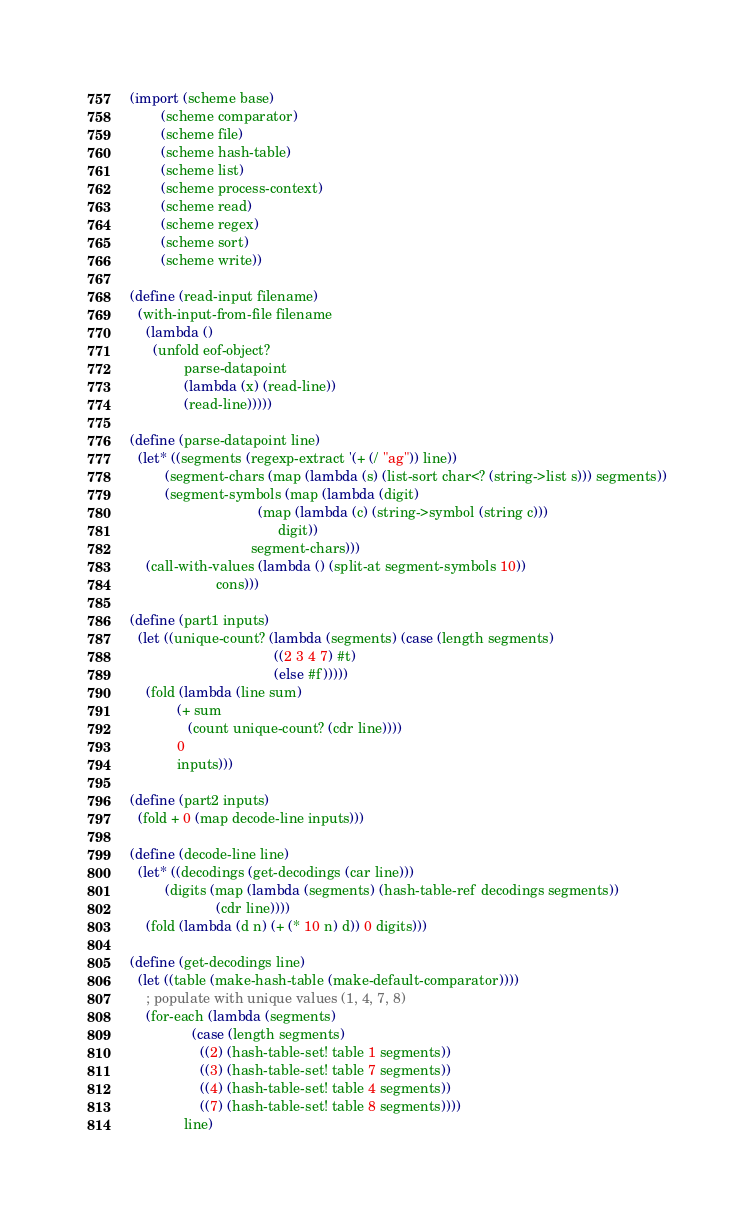<code> <loc_0><loc_0><loc_500><loc_500><_Scheme_>(import (scheme base)
        (scheme comparator)
        (scheme file)
        (scheme hash-table)
        (scheme list)
        (scheme process-context)
        (scheme read)
        (scheme regex)
        (scheme sort)
        (scheme write))

(define (read-input filename)
  (with-input-from-file filename
    (lambda ()
      (unfold eof-object?
              parse-datapoint
              (lambda (x) (read-line))
              (read-line)))))

(define (parse-datapoint line)
  (let* ((segments (regexp-extract '(+ (/ "ag")) line))
         (segment-chars (map (lambda (s) (list-sort char<? (string->list s))) segments))
         (segment-symbols (map (lambda (digit)
                                 (map (lambda (c) (string->symbol (string c)))
                                      digit))
                               segment-chars)))
    (call-with-values (lambda () (split-at segment-symbols 10))
                      cons)))

(define (part1 inputs)
  (let ((unique-count? (lambda (segments) (case (length segments)
                                     ((2 3 4 7) #t)
                                     (else #f)))))
    (fold (lambda (line sum)
            (+ sum
               (count unique-count? (cdr line))))
            0
            inputs)))

(define (part2 inputs)
  (fold + 0 (map decode-line inputs)))

(define (decode-line line)
  (let* ((decodings (get-decodings (car line)))
         (digits (map (lambda (segments) (hash-table-ref decodings segments))
                      (cdr line))))
    (fold (lambda (d n) (+ (* 10 n) d)) 0 digits)))

(define (get-decodings line)
  (let ((table (make-hash-table (make-default-comparator))))
    ; populate with unique values (1, 4, 7, 8)
    (for-each (lambda (segments)
                (case (length segments)
                  ((2) (hash-table-set! table 1 segments))
                  ((3) (hash-table-set! table 7 segments))
                  ((4) (hash-table-set! table 4 segments))
                  ((7) (hash-table-set! table 8 segments))))
              line)</code> 